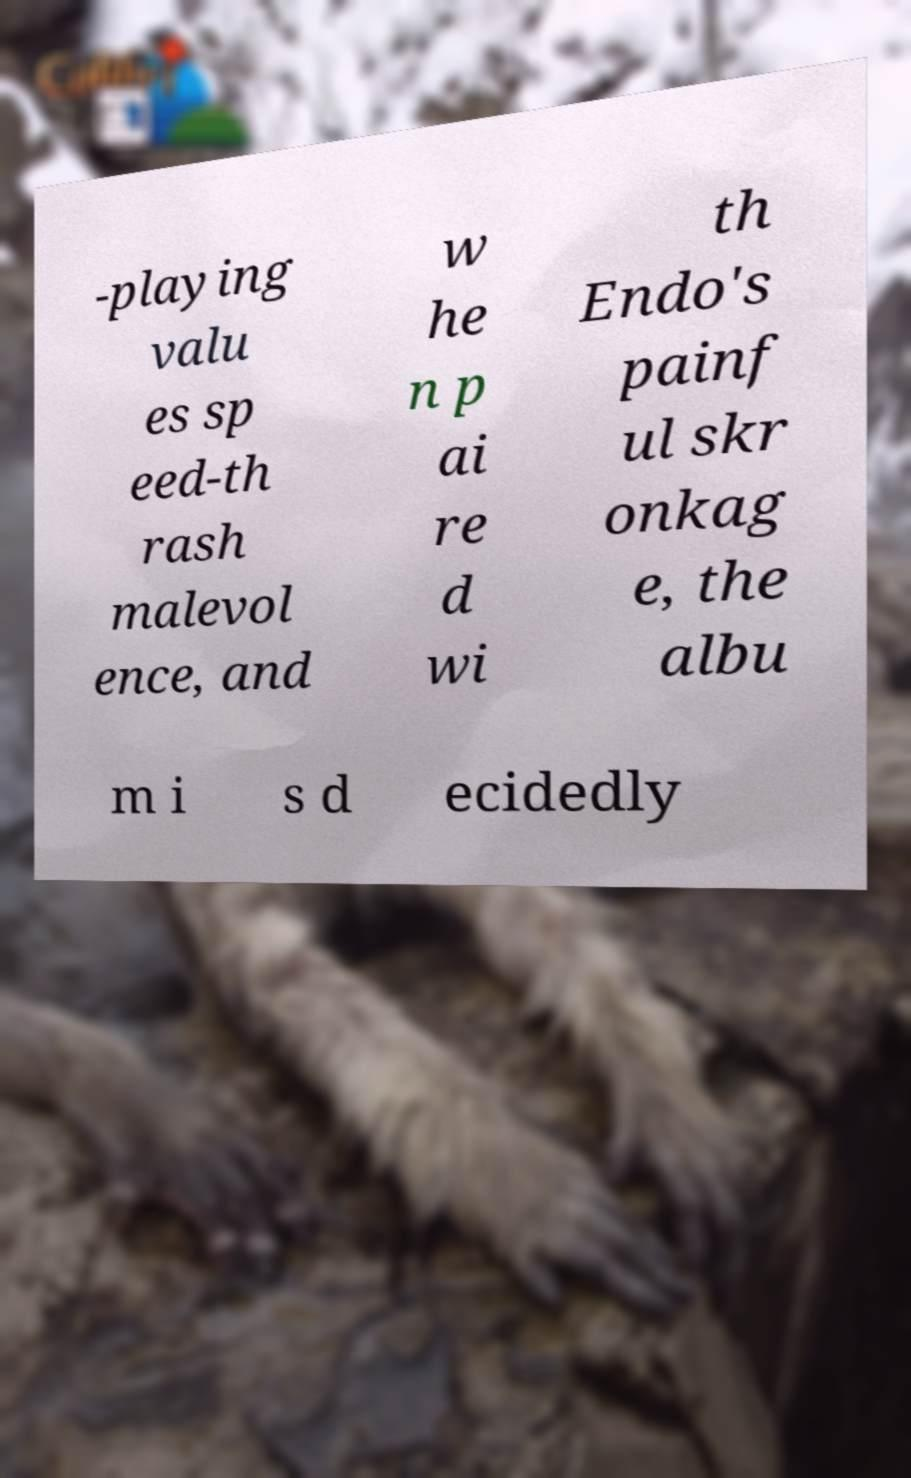I need the written content from this picture converted into text. Can you do that? -playing valu es sp eed-th rash malevol ence, and w he n p ai re d wi th Endo's painf ul skr onkag e, the albu m i s d ecidedly 